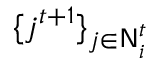<formula> <loc_0><loc_0><loc_500><loc_500>\{ j ^ { t + 1 } \} _ { j \in N _ { i } ^ { t } }</formula> 